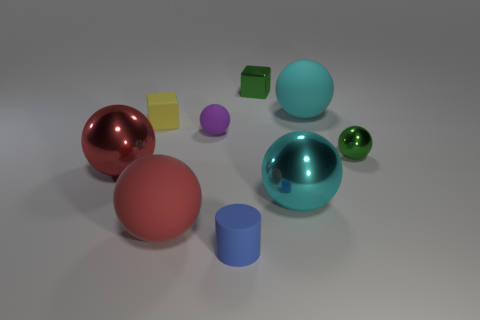What is the cyan thing that is in front of the big thing that is to the left of the big red thing that is to the right of the yellow thing made of?
Your answer should be very brief. Metal. There is a small thing that is the same color as the metal cube; what material is it?
Your answer should be compact. Metal. Do the tiny object in front of the tiny metal sphere and the big matte sphere that is right of the green cube have the same color?
Give a very brief answer. No. What is the shape of the small matte object that is in front of the large metal object to the left of the metallic object that is behind the purple sphere?
Keep it short and to the point. Cylinder. There is a object that is behind the tiny green metallic ball and on the left side of the purple ball; what is its shape?
Give a very brief answer. Cube. There is a small object that is in front of the big shiny object right of the green metal block; what number of large cyan things are on the right side of it?
Your answer should be very brief. 2. What size is the green thing that is the same shape as the yellow matte thing?
Provide a short and direct response. Small. Is there any other thing that is the same size as the cyan metallic thing?
Your answer should be very brief. Yes. Are the small sphere that is in front of the purple sphere and the purple sphere made of the same material?
Offer a very short reply. No. There is another thing that is the same shape as the small yellow rubber thing; what color is it?
Make the answer very short. Green. 